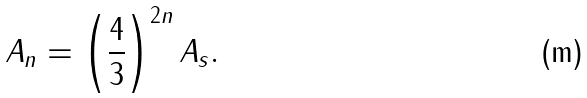<formula> <loc_0><loc_0><loc_500><loc_500>A _ { n } = \left ( \frac { 4 } { 3 } \right ) ^ { 2 n } A _ { s } .</formula> 